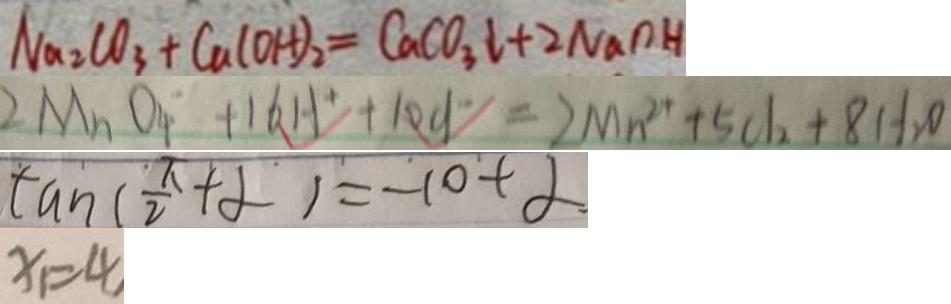<formula> <loc_0><loc_0><loc_500><loc_500>N a _ { 2 } C O _ { 3 } + C a ( O H ) _ { 2 } = C a C O _ { 3 } \downarrow + 2 N a o H 
 2 M n O _ { 4 } ^ { - } + 1 6 H ^ { + } + 1 0 C l ^ { - } = 2 M n ^ { 2 + } + 5 0 1 _ { 2 } + 8 H _ { 2 } O 
 \tan ( \frac { \pi } { 2 } + \alpha ) = - \cot \alpha 
 x _ { 1 } = 4</formula> 